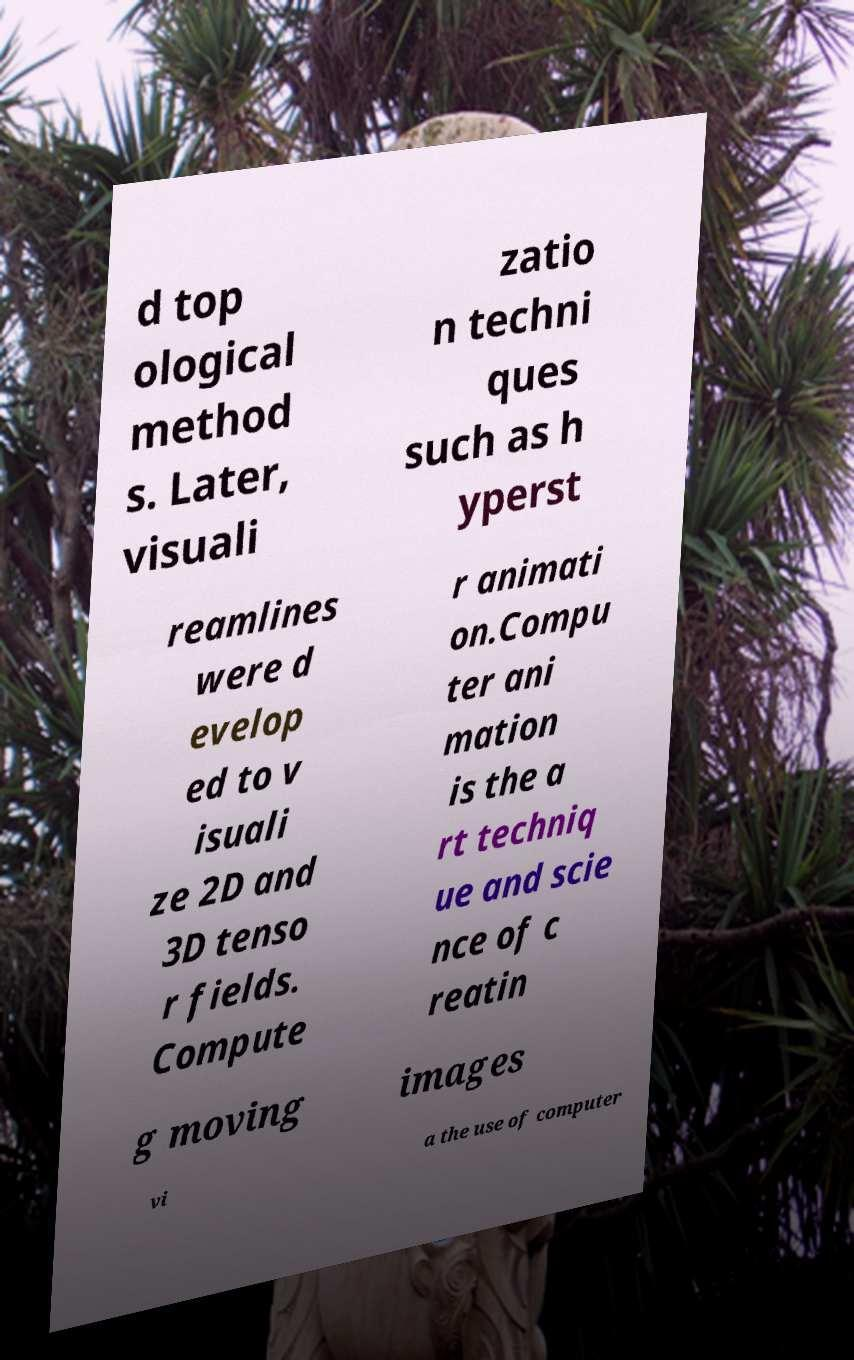Please identify and transcribe the text found in this image. d top ological method s. Later, visuali zatio n techni ques such as h yperst reamlines were d evelop ed to v isuali ze 2D and 3D tenso r fields. Compute r animati on.Compu ter ani mation is the a rt techniq ue and scie nce of c reatin g moving images vi a the use of computer 